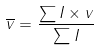Convert formula to latex. <formula><loc_0><loc_0><loc_500><loc_500>\overline { v } = \frac { \sum I \times v } { \sum I }</formula> 